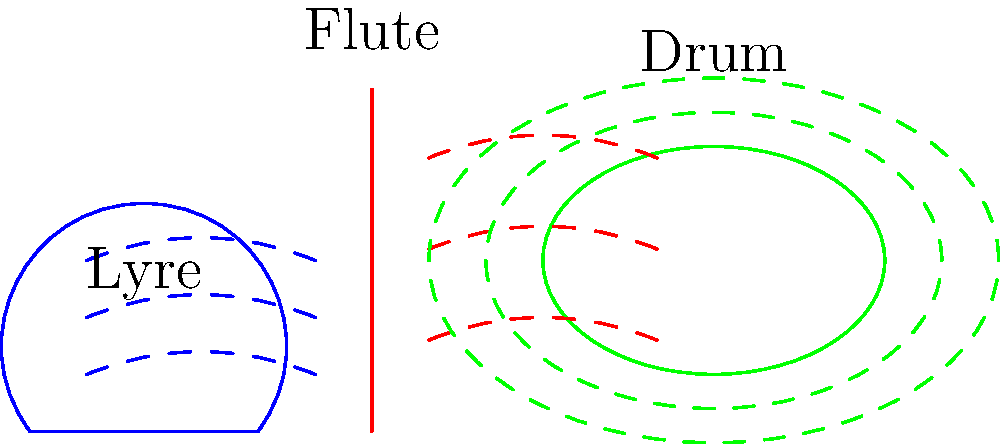In the ancient world, the shape of musical instruments was closely linked to their sound resonance. Comparing the lyre, flute, and drum shown in the diagram, which instrument would likely produce the most varied harmonic overtones, and why? To answer this question, we need to consider the physical properties of each instrument and how they relate to sound production:

1. Lyre:
   - Has a curved body with strings
   - Produces sound through vibrating strings
   - The curved shape allows for multiple string lengths
   - Each string can produce its fundamental frequency and overtones

2. Flute:
   - Straight cylindrical shape
   - Produces sound through air vibrations in a column
   - The length of the air column determines the fundamental frequency
   - Overtones are produced by overblowing or opening/closing holes

3. Drum:
   - Circular shape with a stretched membrane
   - Produces sound through membrane vibration
   - The fundamental frequency is determined by the membrane's tension and size
   - Overtones are limited due to the uniform shape and material

Comparing these instruments:

- The lyre has the most complex shape among the three
- Its multiple strings of varying lengths can produce a wide range of fundamental frequencies
- Each string can also produce its own set of overtones
- The curved body acts as a resonating chamber, enhancing certain frequencies

The flute and drum, while capable of producing overtones, have more limited variability due to their simpler shapes and sound production mechanisms.

Therefore, the lyre would likely produce the most varied harmonic overtones due to its multiple strings of different lengths and its curved resonating body.
Answer: Lyre 